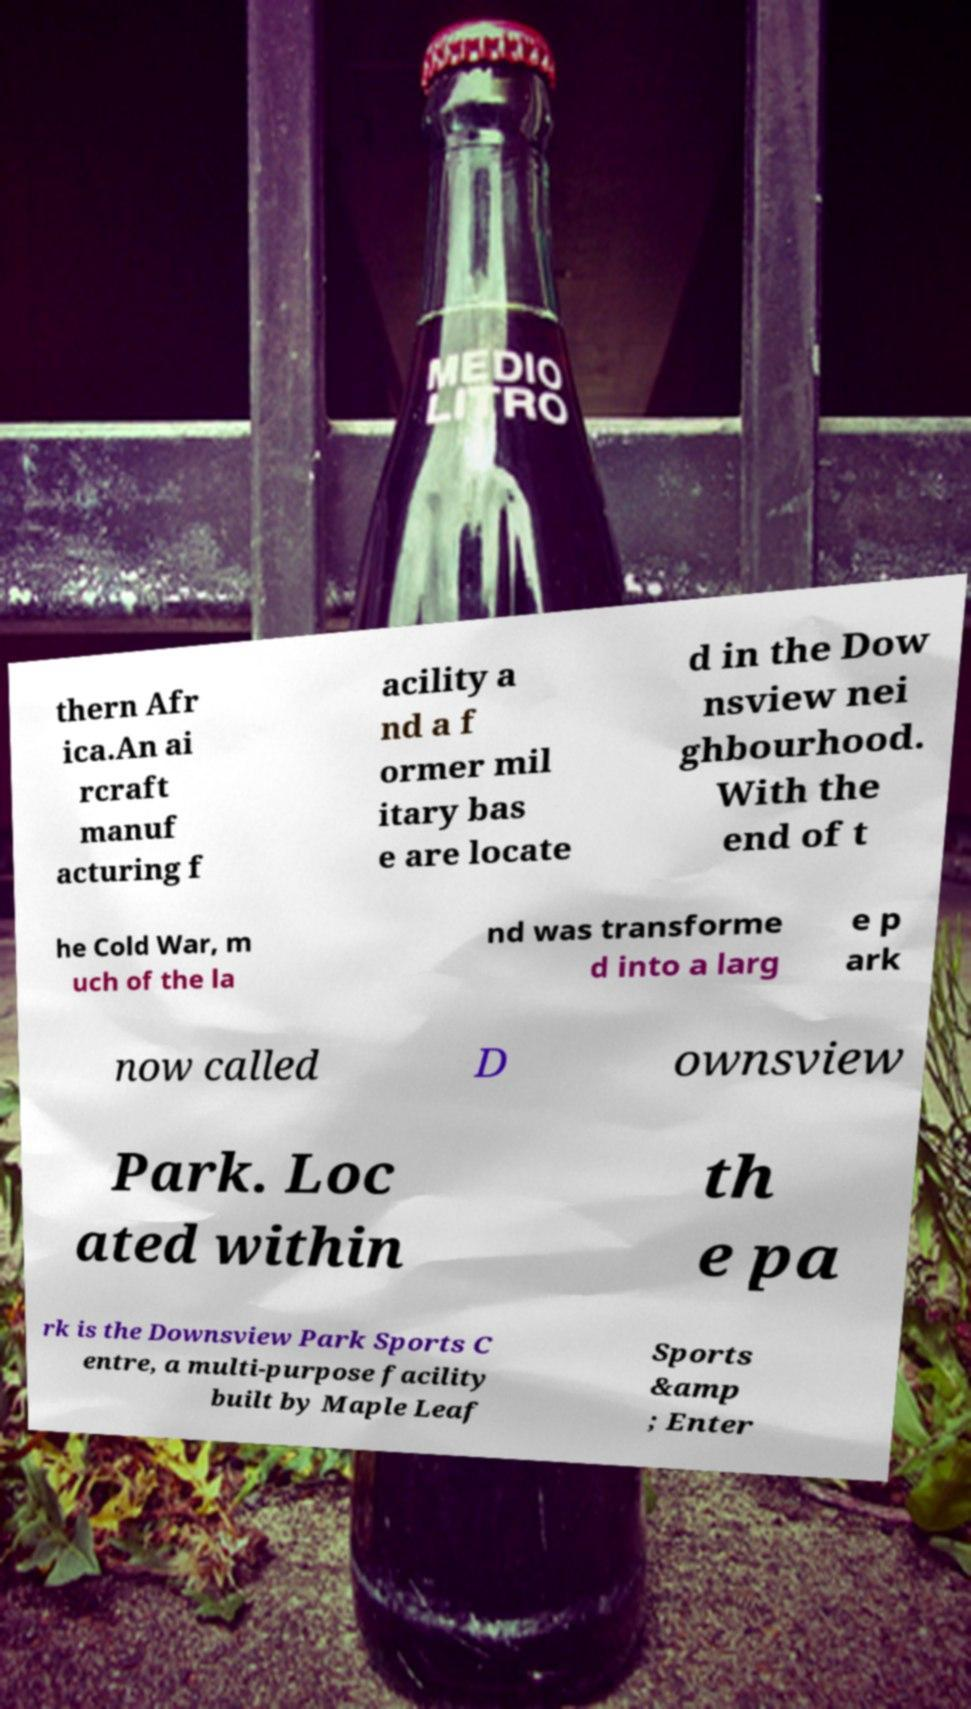There's text embedded in this image that I need extracted. Can you transcribe it verbatim? thern Afr ica.An ai rcraft manuf acturing f acility a nd a f ormer mil itary bas e are locate d in the Dow nsview nei ghbourhood. With the end of t he Cold War, m uch of the la nd was transforme d into a larg e p ark now called D ownsview Park. Loc ated within th e pa rk is the Downsview Park Sports C entre, a multi-purpose facility built by Maple Leaf Sports &amp ; Enter 